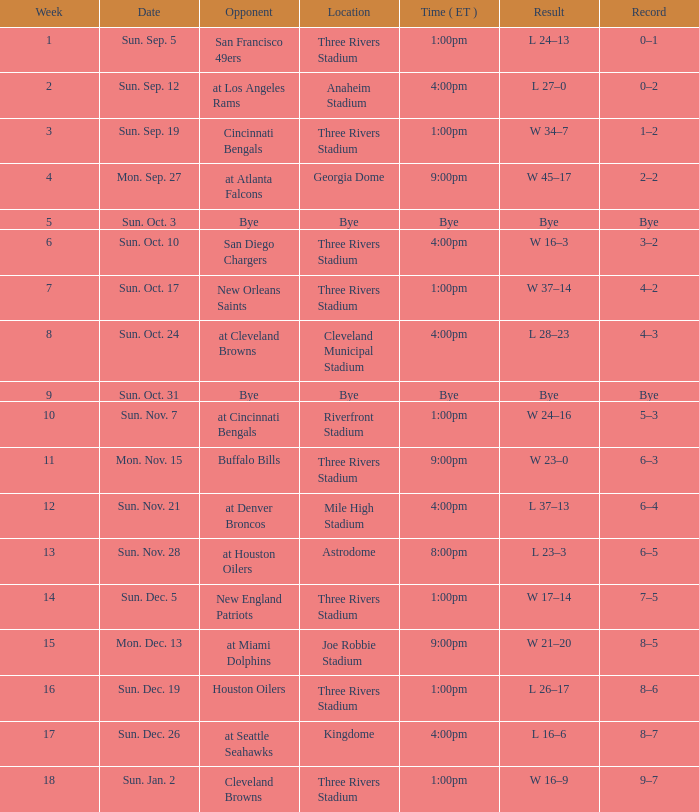Which week displays a game record of 0–1? 1.0. 